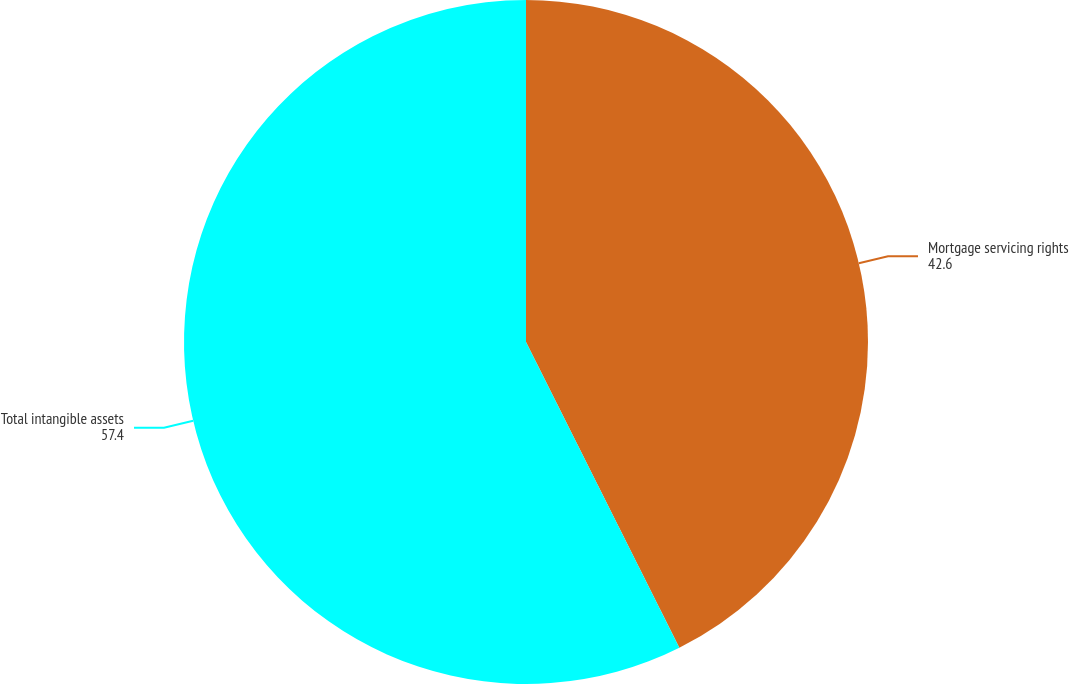Convert chart. <chart><loc_0><loc_0><loc_500><loc_500><pie_chart><fcel>Mortgage servicing rights<fcel>Total intangible assets<nl><fcel>42.6%<fcel>57.4%<nl></chart> 